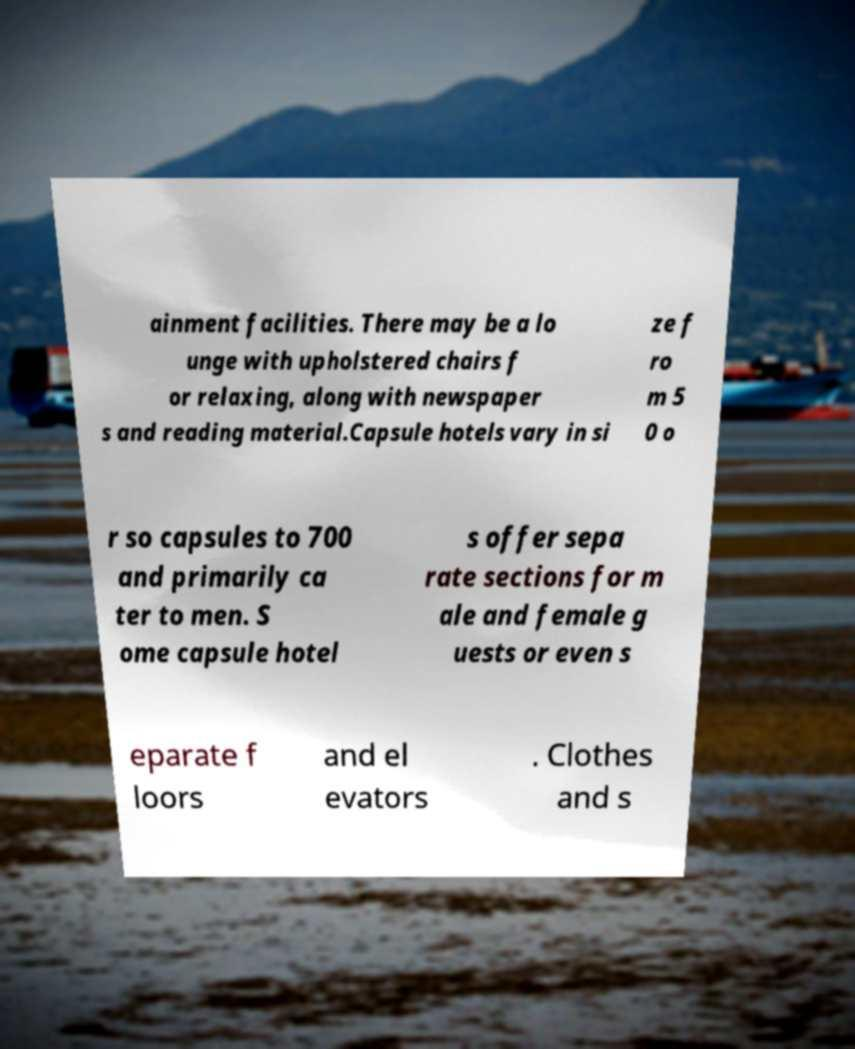Could you extract and type out the text from this image? ainment facilities. There may be a lo unge with upholstered chairs f or relaxing, along with newspaper s and reading material.Capsule hotels vary in si ze f ro m 5 0 o r so capsules to 700 and primarily ca ter to men. S ome capsule hotel s offer sepa rate sections for m ale and female g uests or even s eparate f loors and el evators . Clothes and s 